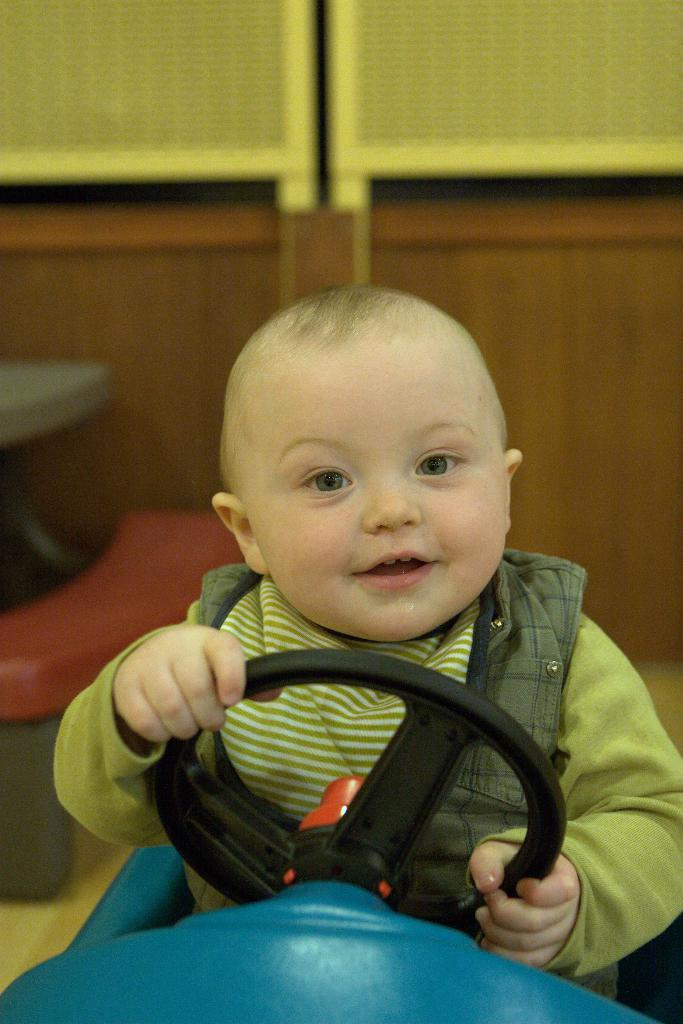Who or what is the main subject in the image? There is a person in the image. What is the person doing in the image? The person is sitting in a toy car. What object is the person holding in the image? The person is holding a steering wheel. What language is the creature speaking in the image? There is no creature present in the image, and therefore no language being spoken. 